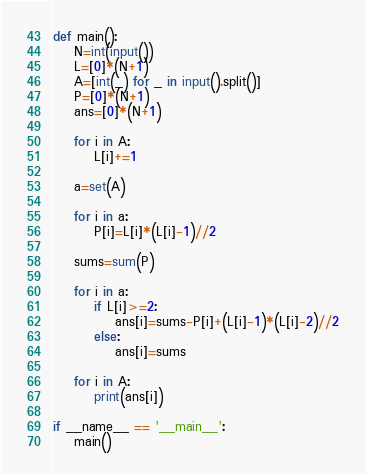<code> <loc_0><loc_0><loc_500><loc_500><_Python_>def main():
    N=int(input())
    L=[0]*(N+1)
    A=[int(_) for _ in input().split()]
    P=[0]*(N+1)
    ans=[0]*(N+1)

    for i in A:
        L[i]+=1

    a=set(A)

    for i in a:
        P[i]=L[i]*(L[i]-1)//2

    sums=sum(P)

    for i in a:
        if L[i]>=2:
            ans[i]=sums-P[i]+(L[i]-1)*(L[i]-2)//2
        else:
            ans[i]=sums

    for i in A:
        print(ans[i])

if __name__ == '__main__':
    main()</code> 